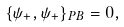Convert formula to latex. <formula><loc_0><loc_0><loc_500><loc_500>\{ \psi _ { + } , \psi _ { + } \} _ { P B } = 0 ,</formula> 